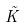Convert formula to latex. <formula><loc_0><loc_0><loc_500><loc_500>\tilde { K }</formula> 